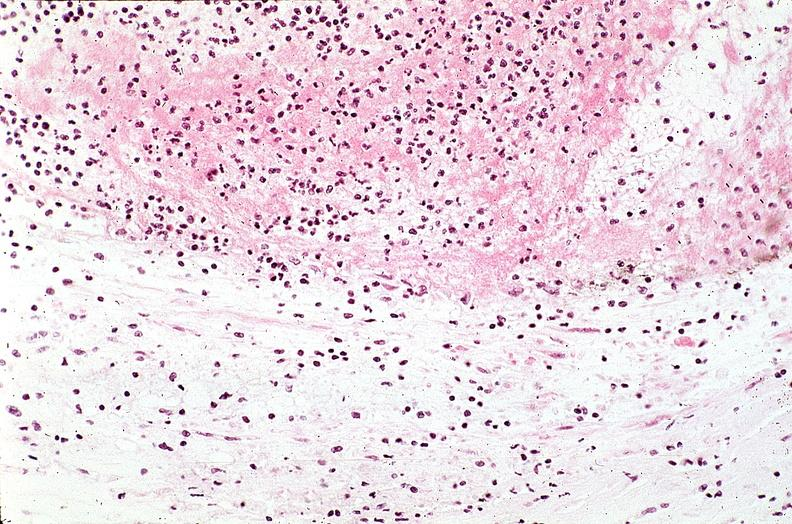s quite good liver present?
Answer the question using a single word or phrase. No 